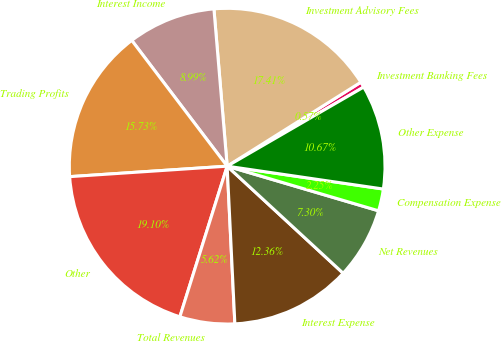<chart> <loc_0><loc_0><loc_500><loc_500><pie_chart><fcel>Investment Banking Fees<fcel>Investment Advisory Fees<fcel>Interest Income<fcel>Trading Profits<fcel>Other<fcel>Total Revenues<fcel>Interest Expense<fcel>Net Revenues<fcel>Compensation Expense<fcel>Other Expense<nl><fcel>0.57%<fcel>17.41%<fcel>8.99%<fcel>15.73%<fcel>19.1%<fcel>5.62%<fcel>12.36%<fcel>7.3%<fcel>2.25%<fcel>10.67%<nl></chart> 